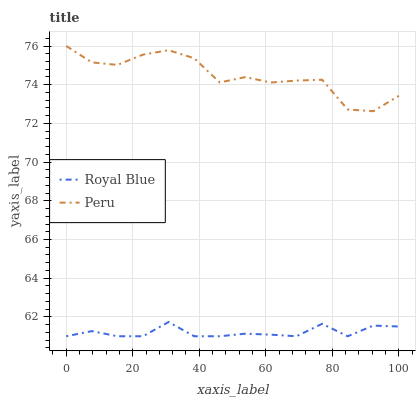Does Royal Blue have the minimum area under the curve?
Answer yes or no. Yes. Does Peru have the maximum area under the curve?
Answer yes or no. Yes. Does Peru have the minimum area under the curve?
Answer yes or no. No. Is Royal Blue the smoothest?
Answer yes or no. Yes. Is Peru the roughest?
Answer yes or no. Yes. Is Peru the smoothest?
Answer yes or no. No. Does Royal Blue have the lowest value?
Answer yes or no. Yes. Does Peru have the lowest value?
Answer yes or no. No. Does Peru have the highest value?
Answer yes or no. Yes. Is Royal Blue less than Peru?
Answer yes or no. Yes. Is Peru greater than Royal Blue?
Answer yes or no. Yes. Does Royal Blue intersect Peru?
Answer yes or no. No. 